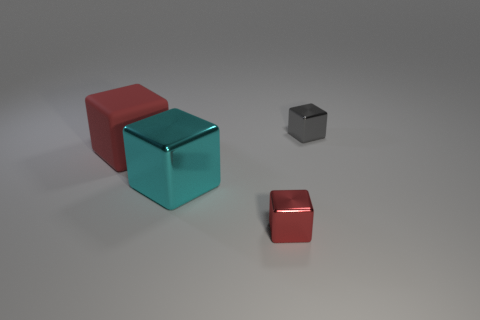How would you describe the arrangement and balance of the objects in this composition? The arrangement of objects in the composition exhibits a sense of minimalist balance. The cubes are placed at varying distances, creating depth and a focal point around the central cyan cube. Additionally, the play of colors, red, cyan, and silver, adds visual interest to the scene without overwhelming the viewer. 